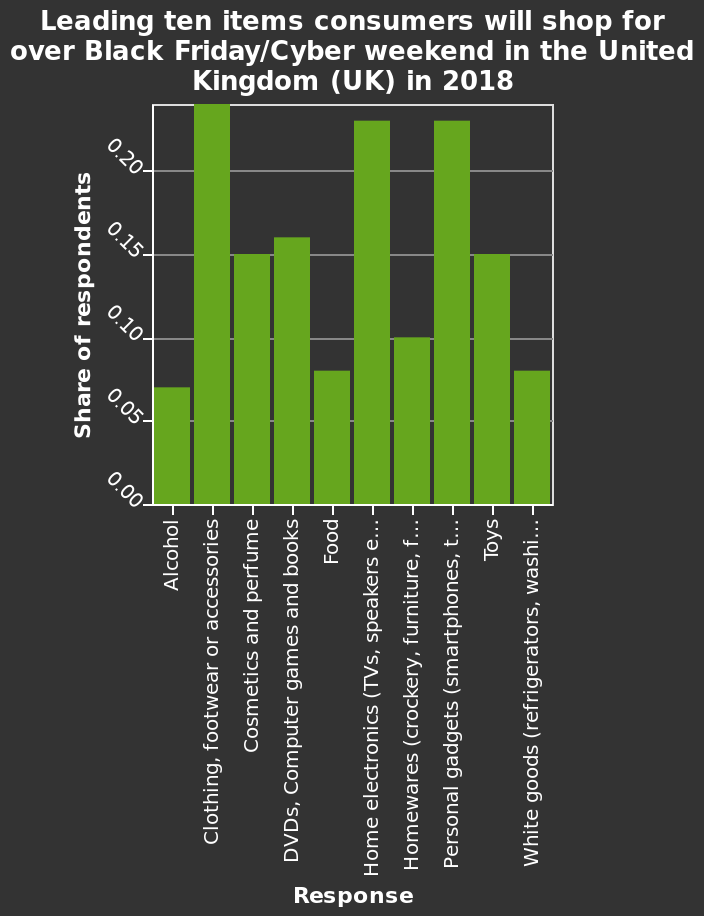<image>
What does the y-axis represent in the bar diagram?  The y-axis represents the Share of respondents on a linear scale. Which category of items had the highest demand on Black Friday?  Clothing, footwear, and accessories had the highest demand on Black Friday. Offer a thorough analysis of the image. Clothing, footwear and accessories was the most popular item purchases on black Friday. The least items purchased were alcohol, food and white goods. What were the least items purchased on Black Friday?  The least items purchased on Black Friday were alcohol, food, and white goods. What items were less popular among shoppers on Black Friday?  Alcohol, food, and white goods were less popular among shoppers on Black Friday. What were the top and bottom categories in terms of purchases on Black Friday? The top category in terms of purchases on Black Friday was clothing, footwear, and accessories, while the bottom categories were alcohol, food, and white goods. Does the y-axis represent the Share of respondents on a logarithmic scale? No. The y-axis represents the Share of respondents on a linear scale. 